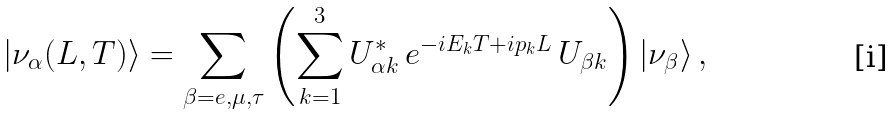Convert formula to latex. <formula><loc_0><loc_0><loc_500><loc_500>| \nu _ { \alpha } ( L , T ) \rangle = \sum _ { \beta = e , \mu , \tau } \left ( \sum _ { k = 1 } ^ { 3 } U _ { \alpha k } ^ { * } \, e ^ { - i E _ { k } T + i p _ { k } L } \, U _ { \beta k } \right ) | \nu _ { \beta } \rangle \, ,</formula> 